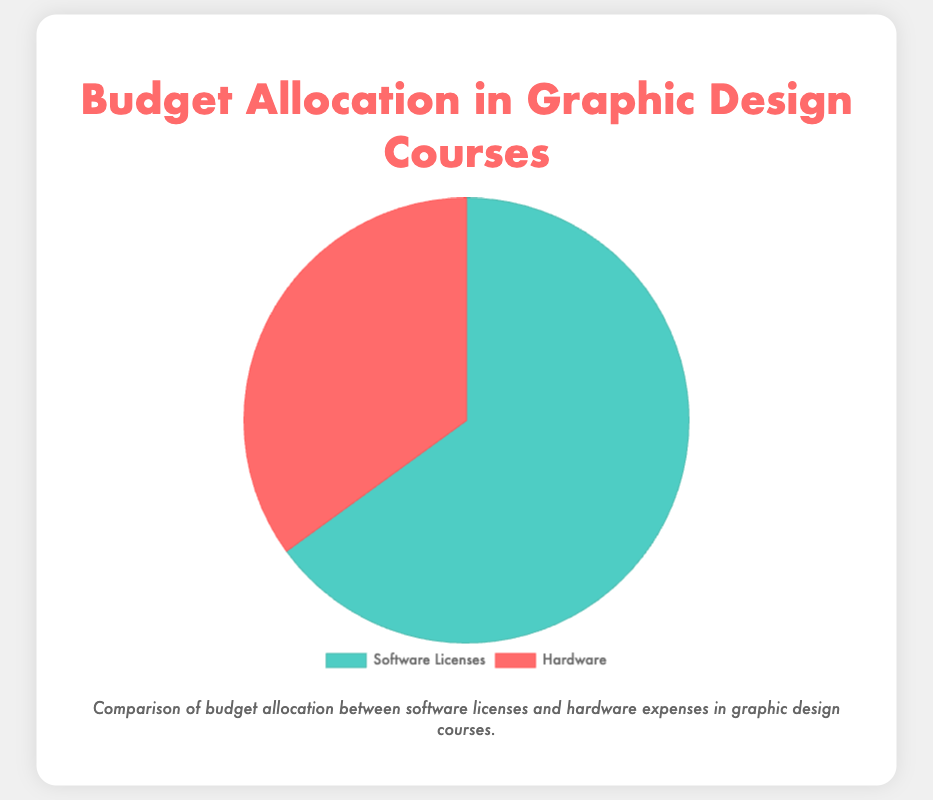What percentage of the budget is allocated for Software Licenses? The Pie chart shows two segments: Software Licenses and Hardware. The Software Licenses slice represents 65% of the total budget.
Answer: 65% How does the budget for Hardware compare to the budget for Software Licenses? The Pie chart shows Software Licenses use 65% of the budget and Hardware use 35% of the budget. By comparing the two percentages, we see that the budget for Software Licenses is almost double that of Hardware.
Answer: Software Licenses have almost double the budget of Hardware Which category has the larger budget allocation, Software Licenses or Hardware? The Pie chart displays two slices, with Software Licenses at 65% and Hardware at 35%. The slice representing Software Licenses is larger.
Answer: Software Licenses What are the primary components of the budget allocated for Software Licenses? The details section specifies the categories: Adobe Creative Cloud, AutoDesk, CorelDRAW, and Figma.
Answer: Adobe Creative Cloud, AutoDesk, CorelDRAW, and Figma If the budget were equally distributed between Software Licenses and Hardware, what would each category's percentage be? If the budget split equally, each category would receive 50%. Currently, Software Licenses is at 65% and Hardware at 35%, which isn't equal.
Answer: 50% What is the magnitude of difference between the budgets for Software Licenses and Hardware? The difference between the Software Licenses budget (65%) and the Hardware budget (35%) is calculated as 65% - 35% = 30%.
Answer: 30% Which category contributes more to the overall budget, Software Licenses' Adobe Creative Cloud or the entire Hardware category? Adobe Creative Cloud uses 45% of the total budget, as outlined in the details. The Hardware category in total uses 35%, which is less than Adobe Creative Cloud on its own.
Answer: Adobe Creative Cloud If the Hardware budget increased by 15%, what would its new percentage be? The current Hardware budget is 35%. Adding 15% gives a new total of 35% + 15% = 50%.
Answer: 50% What color represents Hardware on the Pie chart? The Pie chart uses a distinctive color for each category, with Hardware represented in a red shade.
Answer: Red If the Software Licenses budget allocation decreased by 10%, what would their new percentage be? The current Software Licenses budget allocation is 65%. Decreasing it by 10% gives 65% - 10% = 55%.
Answer: 55% 